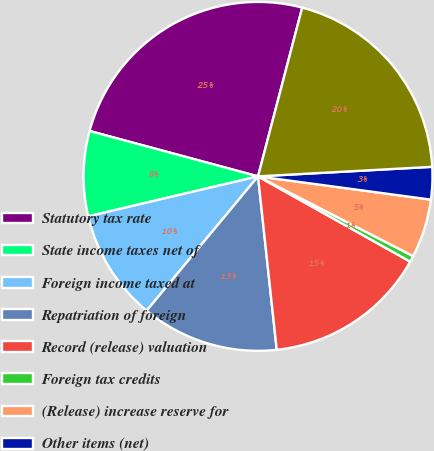<chart> <loc_0><loc_0><loc_500><loc_500><pie_chart><fcel>Statutory tax rate<fcel>State income taxes net of<fcel>Foreign income taxed at<fcel>Repatriation of foreign<fcel>Record (release) valuation<fcel>Foreign tax credits<fcel>(Release) increase reserve for<fcel>Other items (net)<fcel>Effective tax rate<nl><fcel>24.89%<fcel>7.87%<fcel>10.3%<fcel>12.73%<fcel>15.16%<fcel>0.57%<fcel>5.43%<fcel>3.0%<fcel>20.05%<nl></chart> 